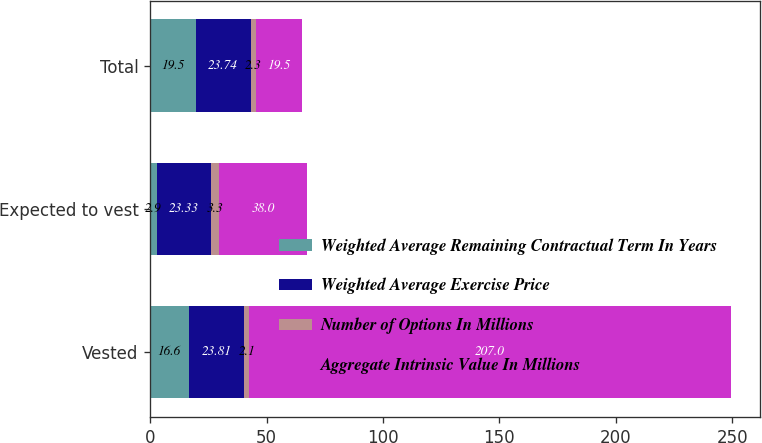Convert chart to OTSL. <chart><loc_0><loc_0><loc_500><loc_500><stacked_bar_chart><ecel><fcel>Vested<fcel>Expected to vest<fcel>Total<nl><fcel>Weighted Average Remaining Contractual Term In Years<fcel>16.6<fcel>2.9<fcel>19.5<nl><fcel>Weighted Average Exercise Price<fcel>23.81<fcel>23.33<fcel>23.74<nl><fcel>Number of Options In Millions<fcel>2.1<fcel>3.3<fcel>2.3<nl><fcel>Aggregate Intrinsic Value In Millions<fcel>207<fcel>38<fcel>19.5<nl></chart> 